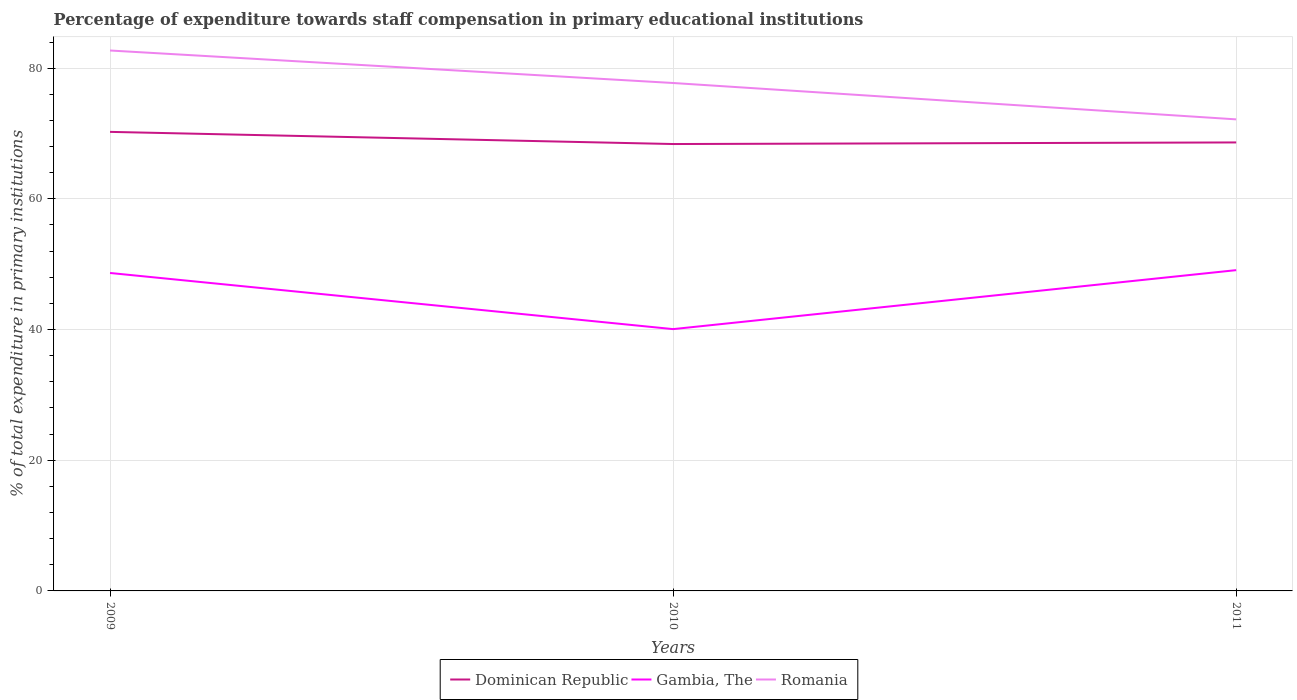How many different coloured lines are there?
Your response must be concise. 3. Across all years, what is the maximum percentage of expenditure towards staff compensation in Romania?
Your response must be concise. 72.16. What is the total percentage of expenditure towards staff compensation in Dominican Republic in the graph?
Your answer should be compact. 1.62. What is the difference between the highest and the second highest percentage of expenditure towards staff compensation in Romania?
Provide a short and direct response. 10.54. What is the difference between the highest and the lowest percentage of expenditure towards staff compensation in Romania?
Ensure brevity in your answer.  2. Is the percentage of expenditure towards staff compensation in Romania strictly greater than the percentage of expenditure towards staff compensation in Dominican Republic over the years?
Provide a short and direct response. No. What is the difference between two consecutive major ticks on the Y-axis?
Provide a short and direct response. 20. How many legend labels are there?
Provide a short and direct response. 3. How are the legend labels stacked?
Provide a short and direct response. Horizontal. What is the title of the graph?
Your answer should be very brief. Percentage of expenditure towards staff compensation in primary educational institutions. What is the label or title of the Y-axis?
Give a very brief answer. % of total expenditure in primary institutions. What is the % of total expenditure in primary institutions of Dominican Republic in 2009?
Ensure brevity in your answer.  70.25. What is the % of total expenditure in primary institutions of Gambia, The in 2009?
Provide a short and direct response. 48.66. What is the % of total expenditure in primary institutions of Romania in 2009?
Ensure brevity in your answer.  82.7. What is the % of total expenditure in primary institutions of Dominican Republic in 2010?
Ensure brevity in your answer.  68.39. What is the % of total expenditure in primary institutions in Gambia, The in 2010?
Ensure brevity in your answer.  40.06. What is the % of total expenditure in primary institutions in Romania in 2010?
Ensure brevity in your answer.  77.73. What is the % of total expenditure in primary institutions in Dominican Republic in 2011?
Ensure brevity in your answer.  68.63. What is the % of total expenditure in primary institutions in Gambia, The in 2011?
Provide a succinct answer. 49.09. What is the % of total expenditure in primary institutions of Romania in 2011?
Keep it short and to the point. 72.16. Across all years, what is the maximum % of total expenditure in primary institutions of Dominican Republic?
Give a very brief answer. 70.25. Across all years, what is the maximum % of total expenditure in primary institutions of Gambia, The?
Ensure brevity in your answer.  49.09. Across all years, what is the maximum % of total expenditure in primary institutions in Romania?
Keep it short and to the point. 82.7. Across all years, what is the minimum % of total expenditure in primary institutions of Dominican Republic?
Make the answer very short. 68.39. Across all years, what is the minimum % of total expenditure in primary institutions of Gambia, The?
Provide a succinct answer. 40.06. Across all years, what is the minimum % of total expenditure in primary institutions of Romania?
Provide a succinct answer. 72.16. What is the total % of total expenditure in primary institutions of Dominican Republic in the graph?
Provide a short and direct response. 207.27. What is the total % of total expenditure in primary institutions of Gambia, The in the graph?
Ensure brevity in your answer.  137.81. What is the total % of total expenditure in primary institutions in Romania in the graph?
Ensure brevity in your answer.  232.59. What is the difference between the % of total expenditure in primary institutions of Dominican Republic in 2009 and that in 2010?
Your answer should be very brief. 1.86. What is the difference between the % of total expenditure in primary institutions in Gambia, The in 2009 and that in 2010?
Give a very brief answer. 8.59. What is the difference between the % of total expenditure in primary institutions in Romania in 2009 and that in 2010?
Ensure brevity in your answer.  4.97. What is the difference between the % of total expenditure in primary institutions in Dominican Republic in 2009 and that in 2011?
Your answer should be very brief. 1.62. What is the difference between the % of total expenditure in primary institutions of Gambia, The in 2009 and that in 2011?
Offer a very short reply. -0.43. What is the difference between the % of total expenditure in primary institutions of Romania in 2009 and that in 2011?
Your answer should be compact. 10.54. What is the difference between the % of total expenditure in primary institutions of Dominican Republic in 2010 and that in 2011?
Offer a terse response. -0.24. What is the difference between the % of total expenditure in primary institutions of Gambia, The in 2010 and that in 2011?
Keep it short and to the point. -9.03. What is the difference between the % of total expenditure in primary institutions in Romania in 2010 and that in 2011?
Provide a succinct answer. 5.56. What is the difference between the % of total expenditure in primary institutions in Dominican Republic in 2009 and the % of total expenditure in primary institutions in Gambia, The in 2010?
Your answer should be very brief. 30.18. What is the difference between the % of total expenditure in primary institutions in Dominican Republic in 2009 and the % of total expenditure in primary institutions in Romania in 2010?
Keep it short and to the point. -7.48. What is the difference between the % of total expenditure in primary institutions in Gambia, The in 2009 and the % of total expenditure in primary institutions in Romania in 2010?
Your answer should be compact. -29.07. What is the difference between the % of total expenditure in primary institutions of Dominican Republic in 2009 and the % of total expenditure in primary institutions of Gambia, The in 2011?
Make the answer very short. 21.16. What is the difference between the % of total expenditure in primary institutions of Dominican Republic in 2009 and the % of total expenditure in primary institutions of Romania in 2011?
Give a very brief answer. -1.91. What is the difference between the % of total expenditure in primary institutions in Gambia, The in 2009 and the % of total expenditure in primary institutions in Romania in 2011?
Provide a succinct answer. -23.51. What is the difference between the % of total expenditure in primary institutions in Dominican Republic in 2010 and the % of total expenditure in primary institutions in Gambia, The in 2011?
Provide a succinct answer. 19.3. What is the difference between the % of total expenditure in primary institutions of Dominican Republic in 2010 and the % of total expenditure in primary institutions of Romania in 2011?
Your answer should be very brief. -3.77. What is the difference between the % of total expenditure in primary institutions of Gambia, The in 2010 and the % of total expenditure in primary institutions of Romania in 2011?
Offer a terse response. -32.1. What is the average % of total expenditure in primary institutions of Dominican Republic per year?
Provide a short and direct response. 69.09. What is the average % of total expenditure in primary institutions of Gambia, The per year?
Offer a very short reply. 45.94. What is the average % of total expenditure in primary institutions of Romania per year?
Offer a terse response. 77.53. In the year 2009, what is the difference between the % of total expenditure in primary institutions in Dominican Republic and % of total expenditure in primary institutions in Gambia, The?
Provide a short and direct response. 21.59. In the year 2009, what is the difference between the % of total expenditure in primary institutions in Dominican Republic and % of total expenditure in primary institutions in Romania?
Provide a short and direct response. -12.45. In the year 2009, what is the difference between the % of total expenditure in primary institutions in Gambia, The and % of total expenditure in primary institutions in Romania?
Provide a short and direct response. -34.04. In the year 2010, what is the difference between the % of total expenditure in primary institutions in Dominican Republic and % of total expenditure in primary institutions in Gambia, The?
Keep it short and to the point. 28.32. In the year 2010, what is the difference between the % of total expenditure in primary institutions in Dominican Republic and % of total expenditure in primary institutions in Romania?
Provide a succinct answer. -9.34. In the year 2010, what is the difference between the % of total expenditure in primary institutions of Gambia, The and % of total expenditure in primary institutions of Romania?
Offer a very short reply. -37.66. In the year 2011, what is the difference between the % of total expenditure in primary institutions in Dominican Republic and % of total expenditure in primary institutions in Gambia, The?
Your answer should be very brief. 19.54. In the year 2011, what is the difference between the % of total expenditure in primary institutions of Dominican Republic and % of total expenditure in primary institutions of Romania?
Ensure brevity in your answer.  -3.53. In the year 2011, what is the difference between the % of total expenditure in primary institutions in Gambia, The and % of total expenditure in primary institutions in Romania?
Make the answer very short. -23.07. What is the ratio of the % of total expenditure in primary institutions in Dominican Republic in 2009 to that in 2010?
Make the answer very short. 1.03. What is the ratio of the % of total expenditure in primary institutions in Gambia, The in 2009 to that in 2010?
Provide a succinct answer. 1.21. What is the ratio of the % of total expenditure in primary institutions in Romania in 2009 to that in 2010?
Make the answer very short. 1.06. What is the ratio of the % of total expenditure in primary institutions in Dominican Republic in 2009 to that in 2011?
Provide a short and direct response. 1.02. What is the ratio of the % of total expenditure in primary institutions of Gambia, The in 2009 to that in 2011?
Provide a short and direct response. 0.99. What is the ratio of the % of total expenditure in primary institutions in Romania in 2009 to that in 2011?
Offer a terse response. 1.15. What is the ratio of the % of total expenditure in primary institutions in Dominican Republic in 2010 to that in 2011?
Offer a terse response. 1. What is the ratio of the % of total expenditure in primary institutions of Gambia, The in 2010 to that in 2011?
Your answer should be very brief. 0.82. What is the ratio of the % of total expenditure in primary institutions of Romania in 2010 to that in 2011?
Your answer should be very brief. 1.08. What is the difference between the highest and the second highest % of total expenditure in primary institutions of Dominican Republic?
Offer a very short reply. 1.62. What is the difference between the highest and the second highest % of total expenditure in primary institutions in Gambia, The?
Your answer should be compact. 0.43. What is the difference between the highest and the second highest % of total expenditure in primary institutions of Romania?
Your response must be concise. 4.97. What is the difference between the highest and the lowest % of total expenditure in primary institutions in Dominican Republic?
Ensure brevity in your answer.  1.86. What is the difference between the highest and the lowest % of total expenditure in primary institutions of Gambia, The?
Give a very brief answer. 9.03. What is the difference between the highest and the lowest % of total expenditure in primary institutions of Romania?
Make the answer very short. 10.54. 